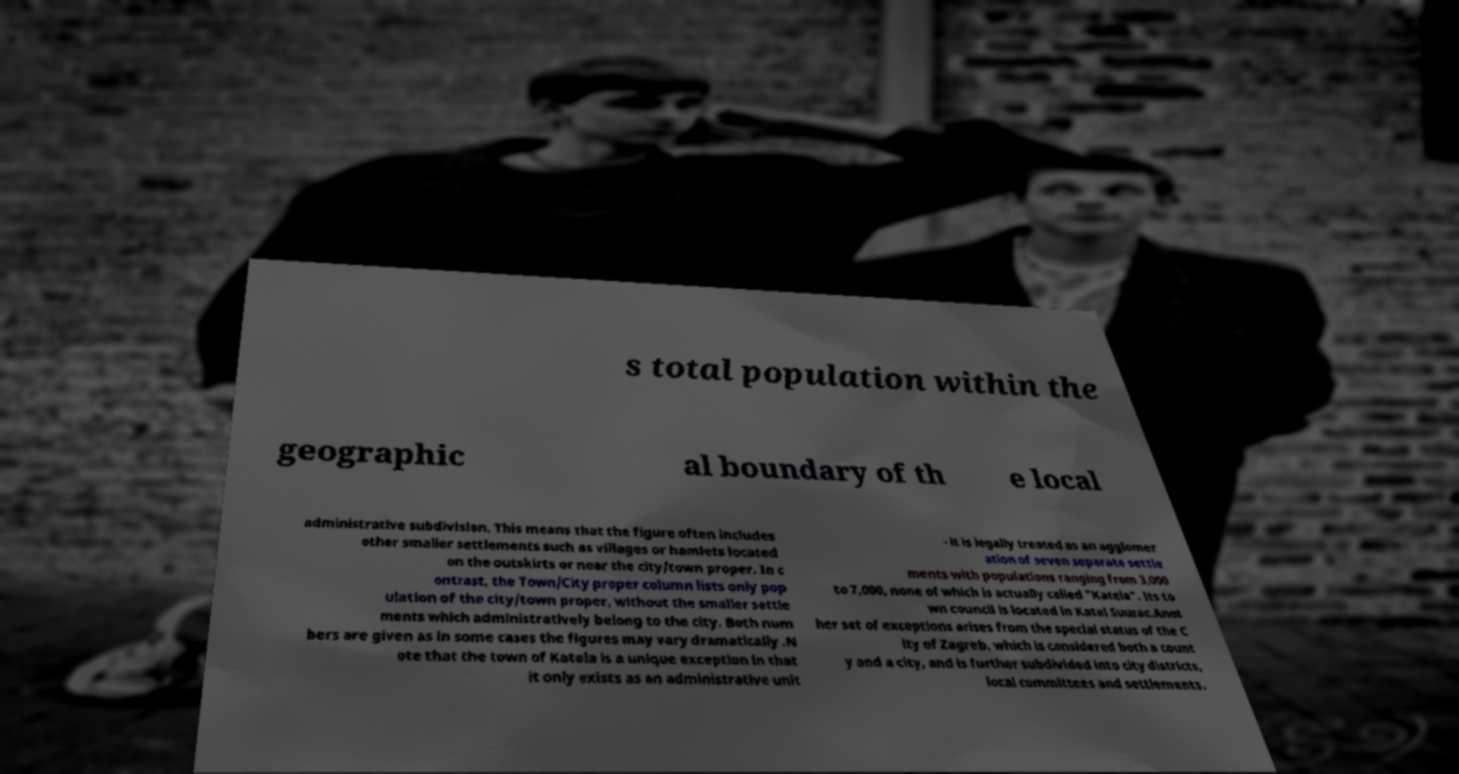For documentation purposes, I need the text within this image transcribed. Could you provide that? s total population within the geographic al boundary of th e local administrative subdivision. This means that the figure often includes other smaller settlements such as villages or hamlets located on the outskirts or near the city/town proper. In c ontrast, the Town/City proper column lists only pop ulation of the city/town proper, without the smaller settle ments which administratively belong to the city. Both num bers are given as in some cases the figures may vary dramatically .N ote that the town of Katela is a unique exception in that it only exists as an administrative unit - it is legally treated as an agglomer ation of seven separate settle ments with populations ranging from 3,000 to 7,000, none of which is actually called "Katela". Its to wn council is located in Katel Suurac.Anot her set of exceptions arises from the special status of the C ity of Zagreb, which is considered both a count y and a city, and is further subdivided into city districts, local committees and settlements. 